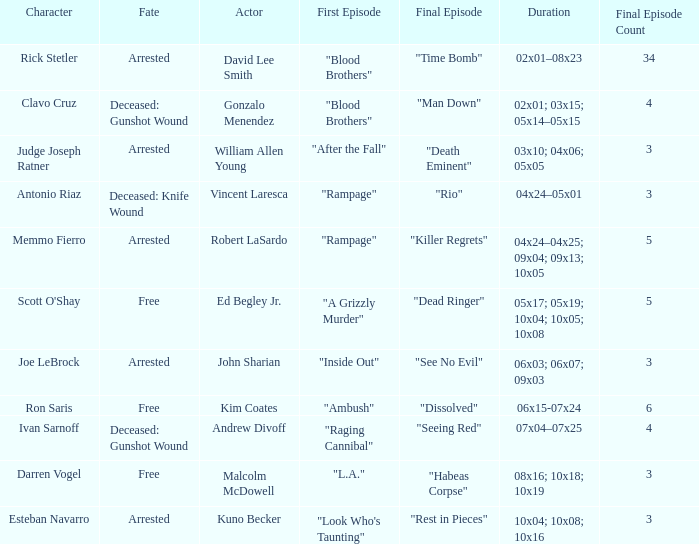What's the complete number of last episodes with the opening episode named "l.a."? 1.0. 